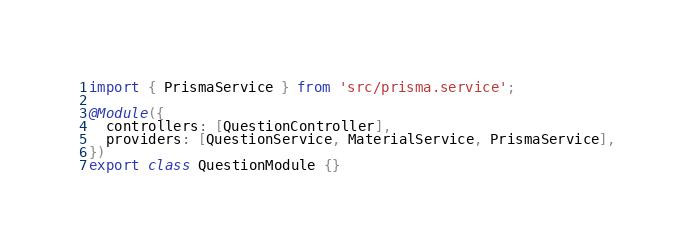Convert code to text. <code><loc_0><loc_0><loc_500><loc_500><_TypeScript_>import { PrismaService } from 'src/prisma.service';

@Module({
  controllers: [QuestionController],
  providers: [QuestionService, MaterialService, PrismaService],
})
export class QuestionModule {}
</code> 